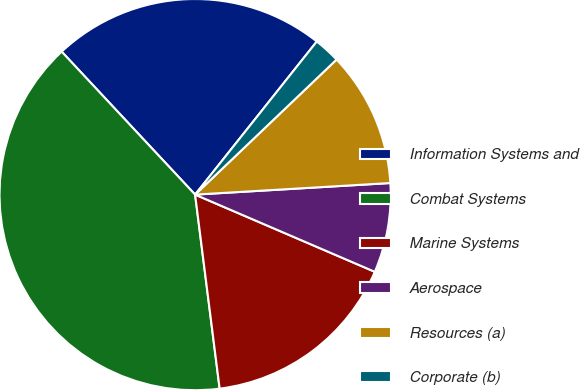Convert chart. <chart><loc_0><loc_0><loc_500><loc_500><pie_chart><fcel>Information Systems and<fcel>Combat Systems<fcel>Marine Systems<fcel>Aerospace<fcel>Resources (a)<fcel>Corporate (b)<nl><fcel>22.64%<fcel>40.05%<fcel>16.54%<fcel>7.4%<fcel>11.19%<fcel>2.18%<nl></chart> 